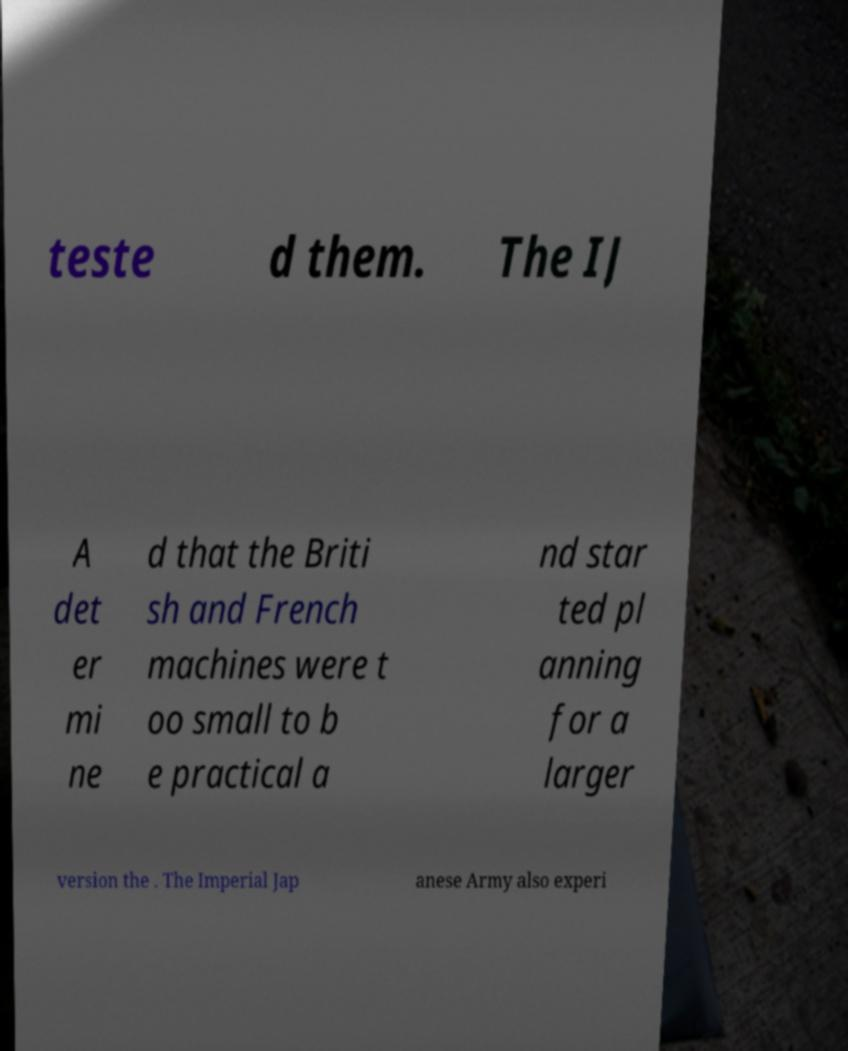There's text embedded in this image that I need extracted. Can you transcribe it verbatim? teste d them. The IJ A det er mi ne d that the Briti sh and French machines were t oo small to b e practical a nd star ted pl anning for a larger version the . The Imperial Jap anese Army also experi 